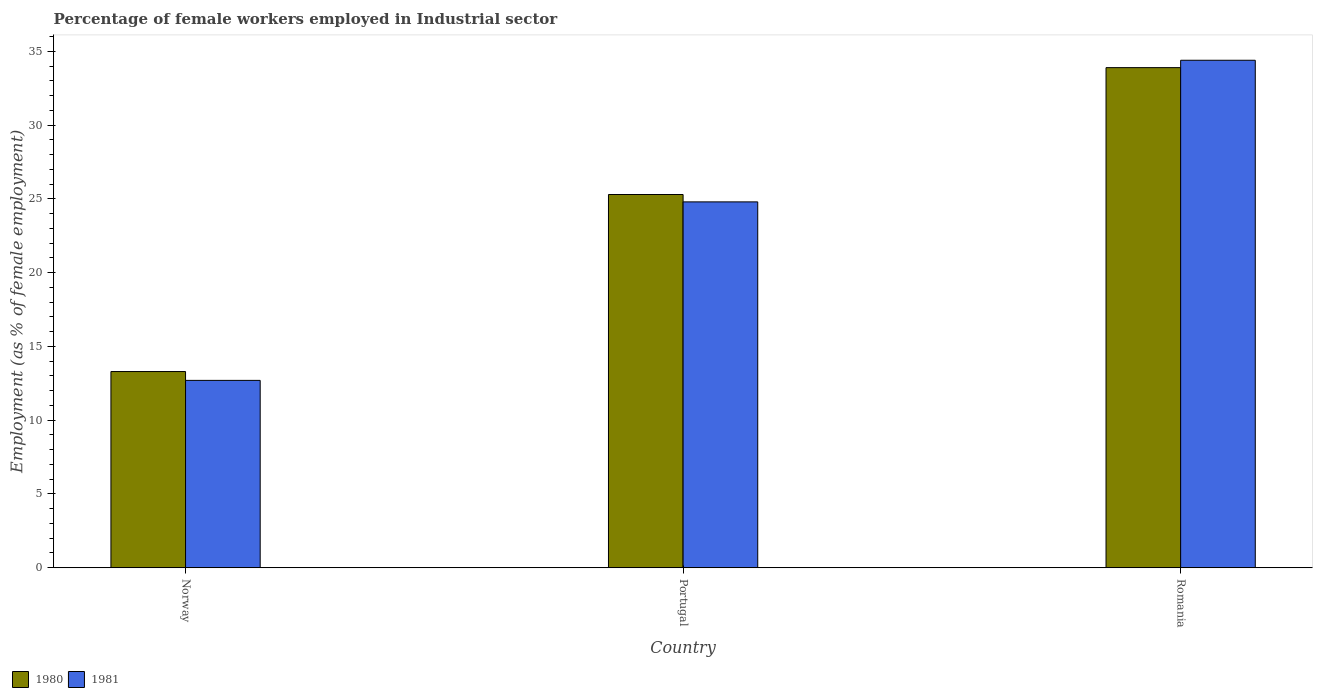How many bars are there on the 1st tick from the left?
Your answer should be compact. 2. What is the label of the 1st group of bars from the left?
Keep it short and to the point. Norway. What is the percentage of females employed in Industrial sector in 1981 in Norway?
Offer a very short reply. 12.7. Across all countries, what is the maximum percentage of females employed in Industrial sector in 1980?
Make the answer very short. 33.9. Across all countries, what is the minimum percentage of females employed in Industrial sector in 1980?
Give a very brief answer. 13.3. In which country was the percentage of females employed in Industrial sector in 1981 maximum?
Provide a succinct answer. Romania. What is the total percentage of females employed in Industrial sector in 1981 in the graph?
Offer a very short reply. 71.9. What is the difference between the percentage of females employed in Industrial sector in 1980 in Norway and that in Romania?
Ensure brevity in your answer.  -20.6. What is the difference between the percentage of females employed in Industrial sector in 1981 in Portugal and the percentage of females employed in Industrial sector in 1980 in Norway?
Your answer should be very brief. 11.5. What is the average percentage of females employed in Industrial sector in 1981 per country?
Your answer should be very brief. 23.97. What is the difference between the percentage of females employed in Industrial sector of/in 1981 and percentage of females employed in Industrial sector of/in 1980 in Norway?
Make the answer very short. -0.6. In how many countries, is the percentage of females employed in Industrial sector in 1980 greater than 9 %?
Offer a very short reply. 3. What is the ratio of the percentage of females employed in Industrial sector in 1980 in Norway to that in Portugal?
Offer a terse response. 0.53. Is the percentage of females employed in Industrial sector in 1981 in Norway less than that in Romania?
Offer a terse response. Yes. What is the difference between the highest and the second highest percentage of females employed in Industrial sector in 1980?
Your response must be concise. 20.6. What is the difference between the highest and the lowest percentage of females employed in Industrial sector in 1981?
Give a very brief answer. 21.7. What does the 2nd bar from the right in Romania represents?
Provide a succinct answer. 1980. How many bars are there?
Keep it short and to the point. 6. Are all the bars in the graph horizontal?
Your answer should be compact. No. How many countries are there in the graph?
Your answer should be very brief. 3. What is the difference between two consecutive major ticks on the Y-axis?
Offer a very short reply. 5. Does the graph contain grids?
Provide a succinct answer. No. How many legend labels are there?
Offer a very short reply. 2. How are the legend labels stacked?
Make the answer very short. Horizontal. What is the title of the graph?
Ensure brevity in your answer.  Percentage of female workers employed in Industrial sector. Does "2012" appear as one of the legend labels in the graph?
Your answer should be very brief. No. What is the label or title of the X-axis?
Your response must be concise. Country. What is the label or title of the Y-axis?
Keep it short and to the point. Employment (as % of female employment). What is the Employment (as % of female employment) of 1980 in Norway?
Keep it short and to the point. 13.3. What is the Employment (as % of female employment) of 1981 in Norway?
Provide a succinct answer. 12.7. What is the Employment (as % of female employment) in 1980 in Portugal?
Your answer should be compact. 25.3. What is the Employment (as % of female employment) in 1981 in Portugal?
Make the answer very short. 24.8. What is the Employment (as % of female employment) of 1980 in Romania?
Your answer should be very brief. 33.9. What is the Employment (as % of female employment) in 1981 in Romania?
Provide a short and direct response. 34.4. Across all countries, what is the maximum Employment (as % of female employment) of 1980?
Make the answer very short. 33.9. Across all countries, what is the maximum Employment (as % of female employment) in 1981?
Your response must be concise. 34.4. Across all countries, what is the minimum Employment (as % of female employment) of 1980?
Provide a short and direct response. 13.3. Across all countries, what is the minimum Employment (as % of female employment) in 1981?
Offer a terse response. 12.7. What is the total Employment (as % of female employment) in 1980 in the graph?
Ensure brevity in your answer.  72.5. What is the total Employment (as % of female employment) of 1981 in the graph?
Ensure brevity in your answer.  71.9. What is the difference between the Employment (as % of female employment) in 1980 in Norway and that in Romania?
Offer a very short reply. -20.6. What is the difference between the Employment (as % of female employment) in 1981 in Norway and that in Romania?
Provide a short and direct response. -21.7. What is the difference between the Employment (as % of female employment) in 1980 in Portugal and that in Romania?
Give a very brief answer. -8.6. What is the difference between the Employment (as % of female employment) in 1981 in Portugal and that in Romania?
Provide a short and direct response. -9.6. What is the difference between the Employment (as % of female employment) of 1980 in Norway and the Employment (as % of female employment) of 1981 in Portugal?
Offer a terse response. -11.5. What is the difference between the Employment (as % of female employment) of 1980 in Norway and the Employment (as % of female employment) of 1981 in Romania?
Your answer should be compact. -21.1. What is the average Employment (as % of female employment) of 1980 per country?
Make the answer very short. 24.17. What is the average Employment (as % of female employment) in 1981 per country?
Provide a short and direct response. 23.97. What is the difference between the Employment (as % of female employment) in 1980 and Employment (as % of female employment) in 1981 in Norway?
Provide a succinct answer. 0.6. What is the difference between the Employment (as % of female employment) in 1980 and Employment (as % of female employment) in 1981 in Portugal?
Keep it short and to the point. 0.5. What is the difference between the Employment (as % of female employment) of 1980 and Employment (as % of female employment) of 1981 in Romania?
Make the answer very short. -0.5. What is the ratio of the Employment (as % of female employment) in 1980 in Norway to that in Portugal?
Your response must be concise. 0.53. What is the ratio of the Employment (as % of female employment) of 1981 in Norway to that in Portugal?
Provide a succinct answer. 0.51. What is the ratio of the Employment (as % of female employment) of 1980 in Norway to that in Romania?
Your answer should be very brief. 0.39. What is the ratio of the Employment (as % of female employment) in 1981 in Norway to that in Romania?
Offer a terse response. 0.37. What is the ratio of the Employment (as % of female employment) in 1980 in Portugal to that in Romania?
Offer a terse response. 0.75. What is the ratio of the Employment (as % of female employment) of 1981 in Portugal to that in Romania?
Offer a terse response. 0.72. What is the difference between the highest and the second highest Employment (as % of female employment) in 1981?
Make the answer very short. 9.6. What is the difference between the highest and the lowest Employment (as % of female employment) of 1980?
Your response must be concise. 20.6. What is the difference between the highest and the lowest Employment (as % of female employment) of 1981?
Keep it short and to the point. 21.7. 